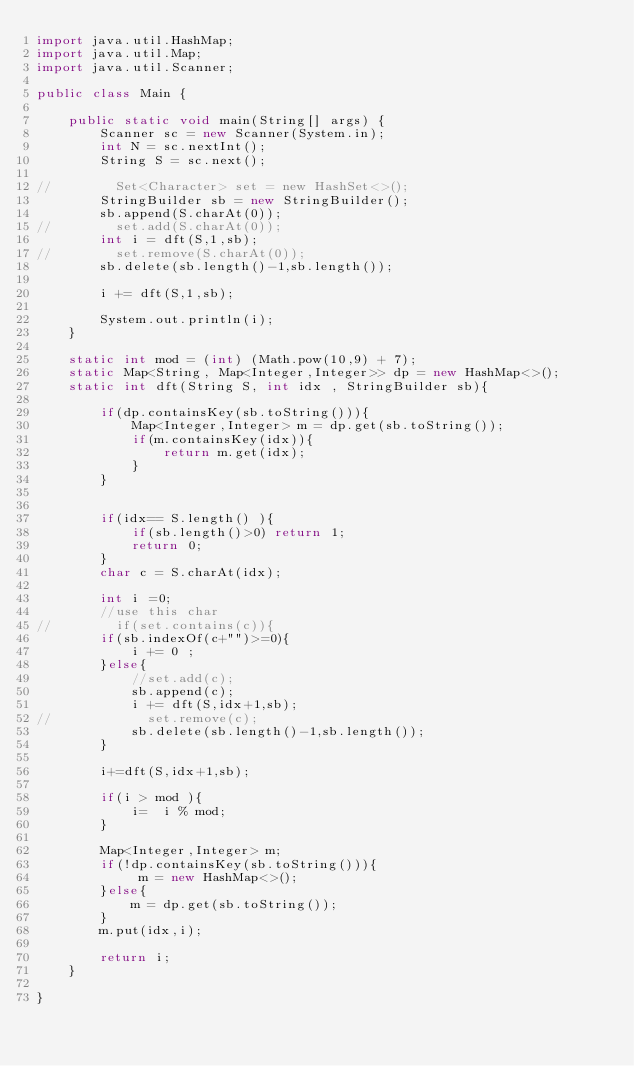<code> <loc_0><loc_0><loc_500><loc_500><_Java_>import java.util.HashMap;
import java.util.Map;
import java.util.Scanner;

public class Main {

    public static void main(String[] args) {
        Scanner sc = new Scanner(System.in);
        int N = sc.nextInt();
        String S = sc.next();

//        Set<Character> set = new HashSet<>();
        StringBuilder sb = new StringBuilder();
        sb.append(S.charAt(0));
//        set.add(S.charAt(0));
        int i = dft(S,1,sb);
//        set.remove(S.charAt(0));
        sb.delete(sb.length()-1,sb.length());

        i += dft(S,1,sb);

        System.out.println(i);
    }

    static int mod = (int) (Math.pow(10,9) + 7);
    static Map<String, Map<Integer,Integer>> dp = new HashMap<>();
    static int dft(String S, int idx , StringBuilder sb){

        if(dp.containsKey(sb.toString())){
            Map<Integer,Integer> m = dp.get(sb.toString());
            if(m.containsKey(idx)){
                return m.get(idx);
            }
        }


        if(idx== S.length() ){
            if(sb.length()>0) return 1;
            return 0;
        }
        char c = S.charAt(idx);

        int i =0;
        //use this char
//        if(set.contains(c)){
        if(sb.indexOf(c+"")>=0){
            i += 0 ;
        }else{
            //set.add(c);
            sb.append(c);
            i += dft(S,idx+1,sb);
//            set.remove(c);
            sb.delete(sb.length()-1,sb.length());
        }

        i+=dft(S,idx+1,sb);

        if(i > mod ){
            i=  i % mod;
        }

        Map<Integer,Integer> m;
        if(!dp.containsKey(sb.toString())){
             m = new HashMap<>();
        }else{
            m = dp.get(sb.toString());
        }
        m.put(idx,i);

        return i;
    }

}
</code> 